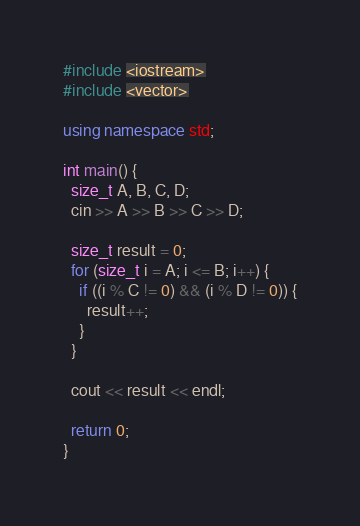<code> <loc_0><loc_0><loc_500><loc_500><_C++_>#include <iostream>
#include <vector>

using namespace std;

int main() {
  size_t A, B, C, D;
  cin >> A >> B >> C >> D;

  size_t result = 0;
  for (size_t i = A; i <= B; i++) {
    if ((i % C != 0) && (i % D != 0)) {
      result++;
    }
  }

  cout << result << endl;

  return 0;
}</code> 